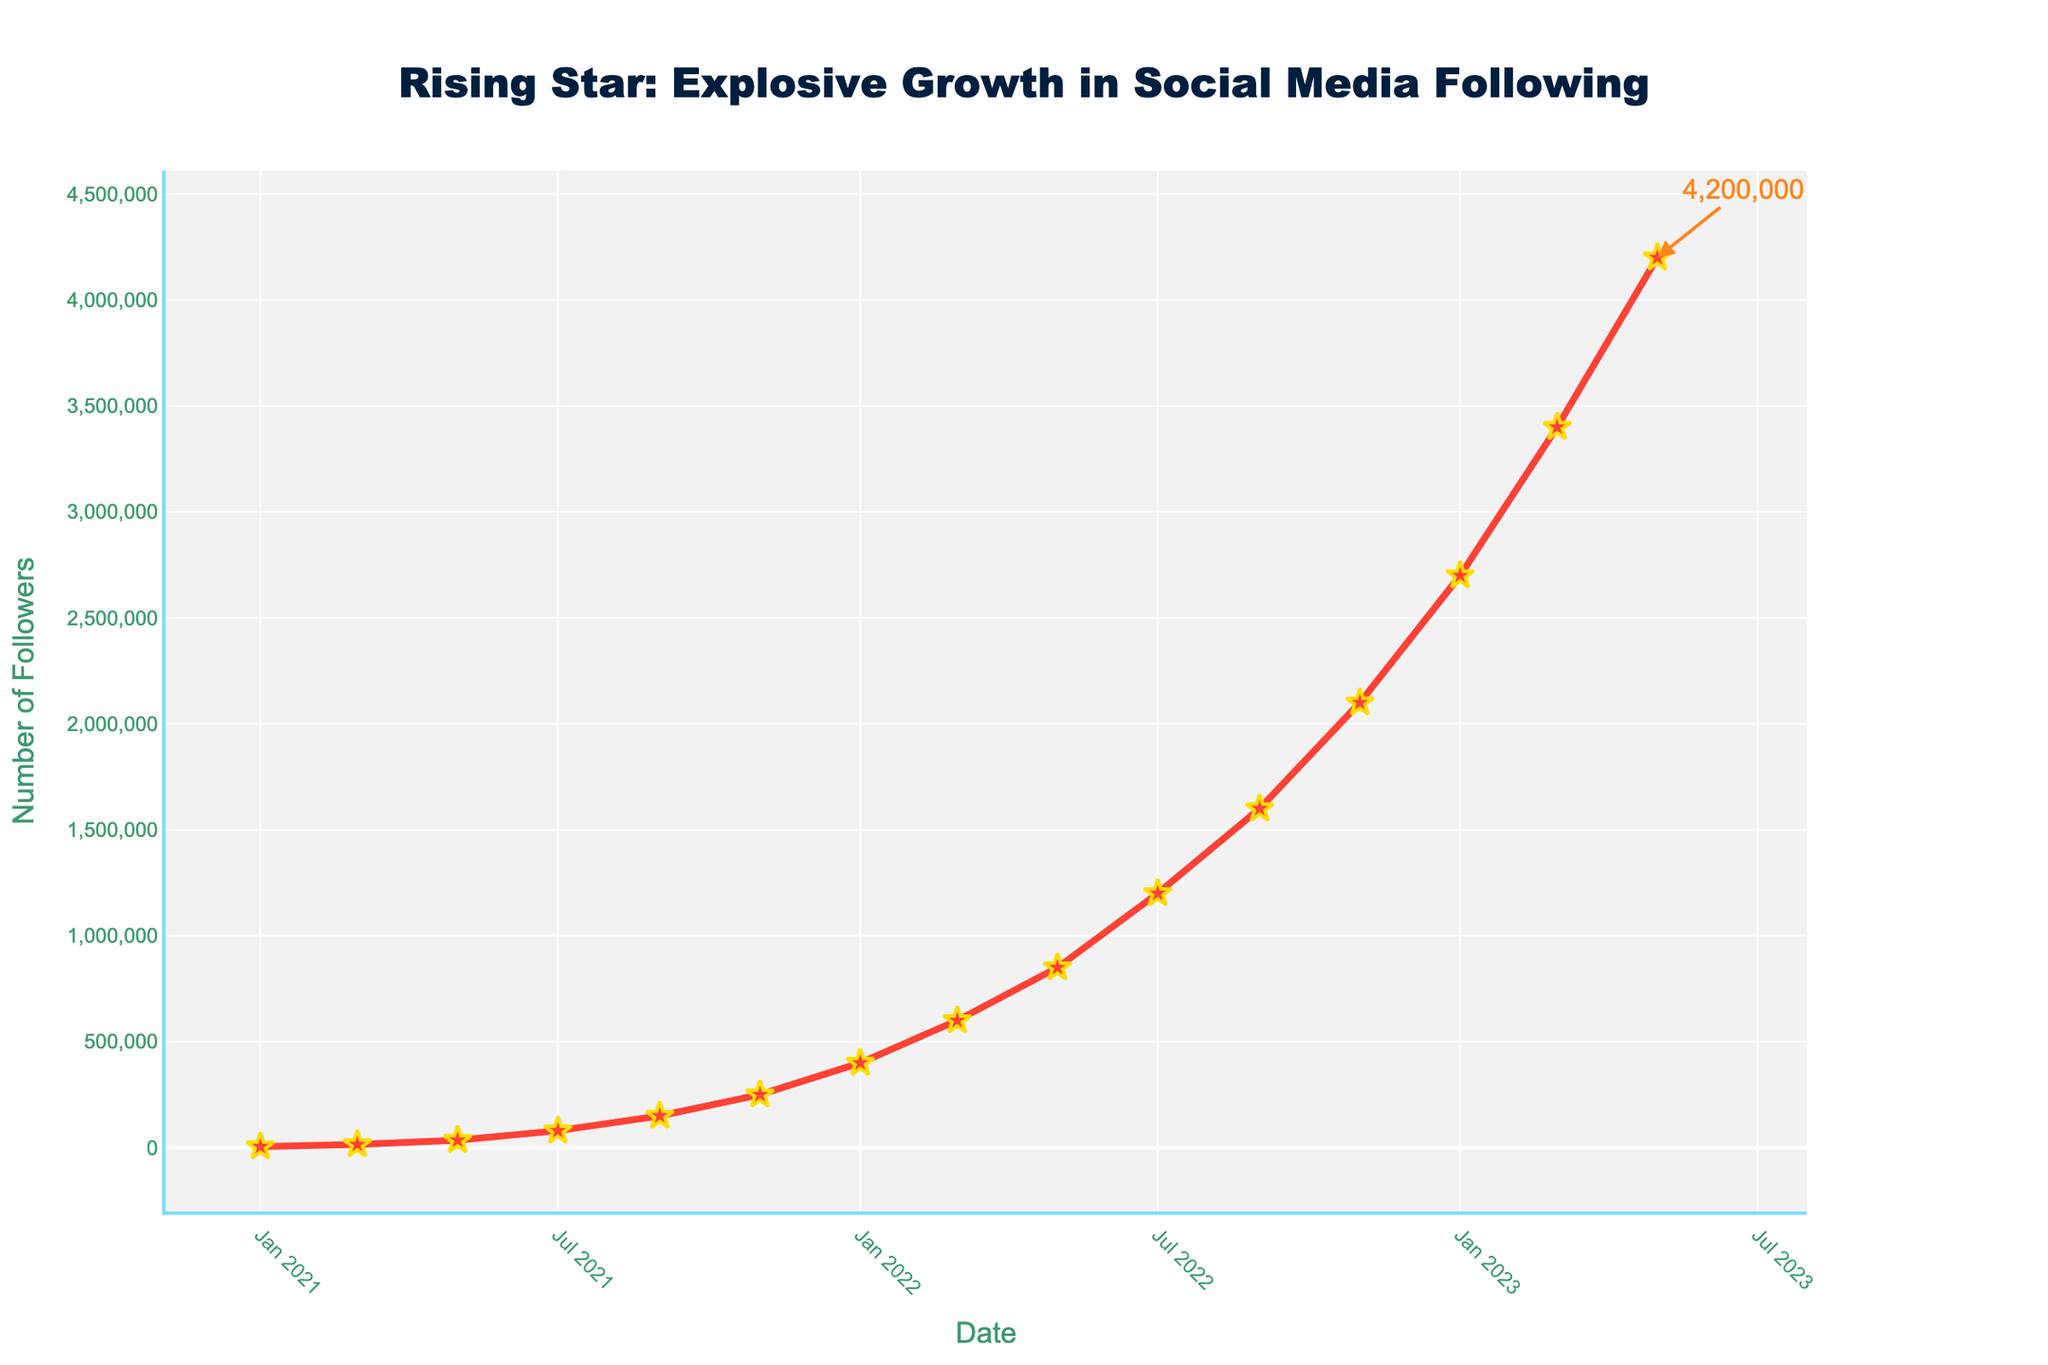How many followers did the fighter gain between September 2022 and March 2023? To find the increase in followers between these dates, look at the followers on September 2022 (1,600,000) and March 2023 (3,400,000). Subtract the earlier number from the later number: 3,400,000 - 1,600,000 = 1,800,000
Answer: 1,800,000 What is the average number of followers gained every two months in 2022? To calculate the average, first find the total number of followers gained over the year. January 2022 had 400,000 followers and January 2023 had 2,700,000 followers. The total gain in 2022 was 2,700,000 - 400,000 = 2,300,000 followers. There are six two-month periods in a year, so the average gain every two months is 2,300,000 / 6 = 383,333.33
Answer: 383,333.33 Which period saw the highest increase in followers? To find the period with the highest increase, compare the follower growth between each two-month period. The highest increase is from January 2023 (2,700,000) to March 2023 (3,400,000), which is an increase of 3,400,000 - 2,700,000 = 700,000
Answer: January 2023 to March 2023 By how much did the follower count increase between January 2021 and January 2022? Compare the number of followers in January 2021 (5,000) to January 2022 (400,000). Subtract the earlier number from the later number: 400,000 - 5,000 = 395,000
Answer: 395,000 How does the growth rate between March 2022 and July 2022 compare to the growth rate between July 2022 and November 2022? First, calculate the growth rate for March 2022 to July 2022: (1,200,000 - 600,000) / 4 months = 150,000 followers/month. Then calculate the growth rate for July 2022 to November 2022: (2,100,000 - 1,200,000) / 4 months = 225,000 followers/month. Compare the two rates: 225,000 is greater than 150,000
Answer: July 2022 to November 2022 has a higher rate What color are the follower line and marker symbols on the chart? The plot shows the line and markers in red with gold trim. The follower line is represented with a red color, and the star markers have a golden outline with red inner color
Answer: Red and Golden outline What is the total number of followers at the end of the data period? The total number of followers at the end, which is May 2023, is marked with an annotation pointing to the last data point. The annotation states 4,200,000
Answer: 4,200,000 